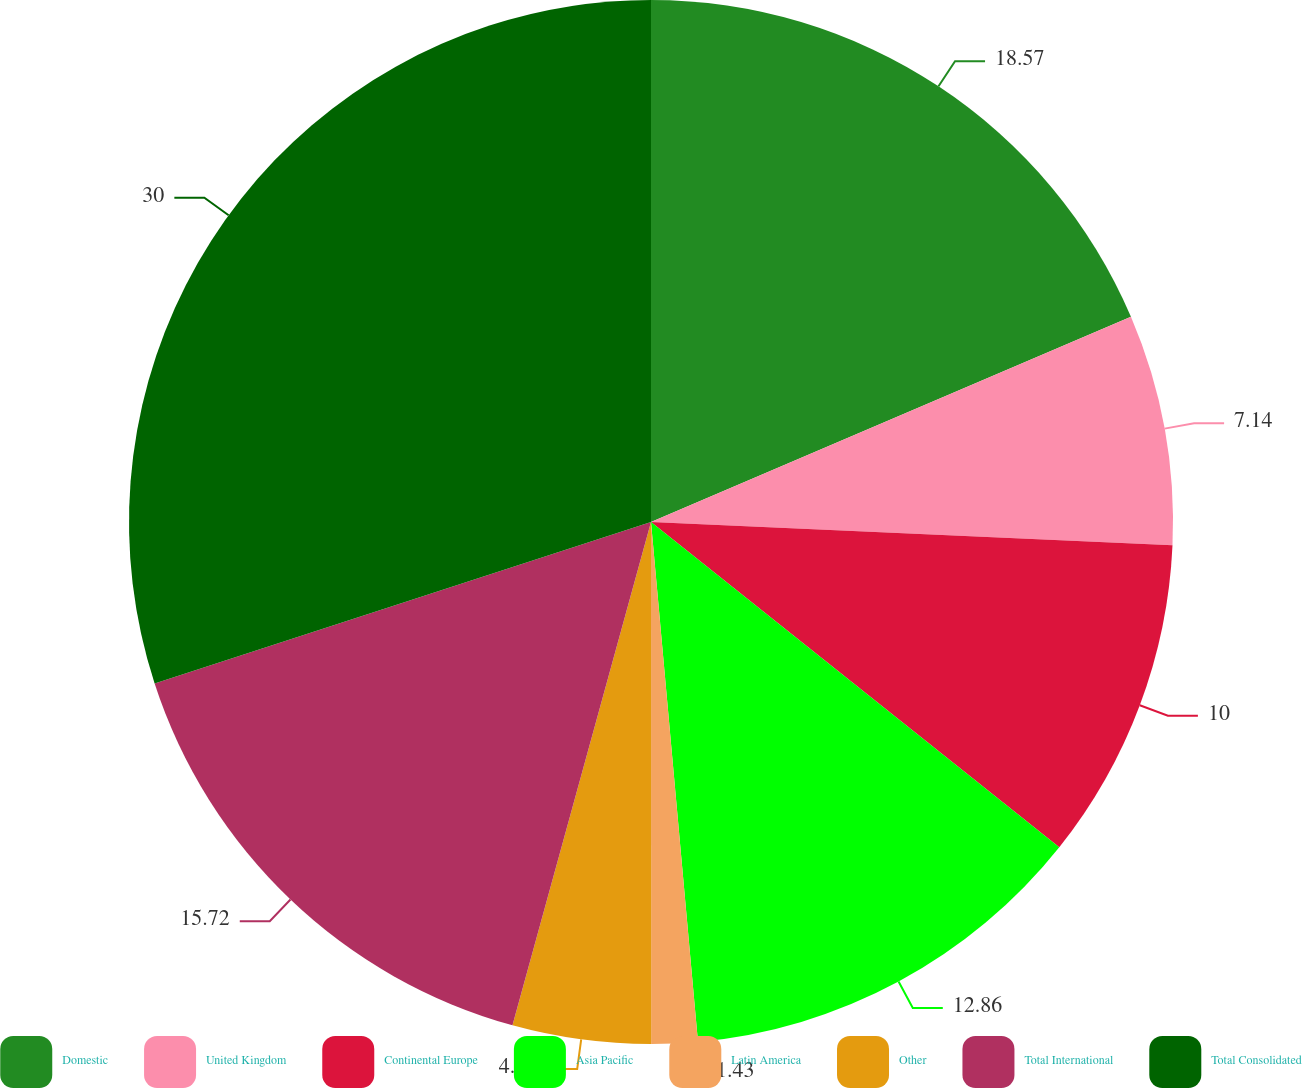Convert chart to OTSL. <chart><loc_0><loc_0><loc_500><loc_500><pie_chart><fcel>Domestic<fcel>United Kingdom<fcel>Continental Europe<fcel>Asia Pacific<fcel>Latin America<fcel>Other<fcel>Total International<fcel>Total Consolidated<nl><fcel>18.57%<fcel>7.14%<fcel>10.0%<fcel>12.86%<fcel>1.43%<fcel>4.28%<fcel>15.72%<fcel>30.01%<nl></chart> 